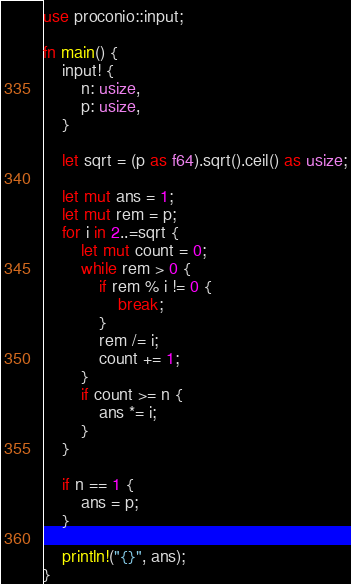Convert code to text. <code><loc_0><loc_0><loc_500><loc_500><_Rust_>use proconio::input;

fn main() {
    input! {
        n: usize,
        p: usize,
    }

    let sqrt = (p as f64).sqrt().ceil() as usize;

    let mut ans = 1;
    let mut rem = p;
    for i in 2..=sqrt {
        let mut count = 0;
        while rem > 0 {
            if rem % i != 0 {
                break;
            } 
            rem /= i;
            count += 1;
        }
        if count >= n {
            ans *= i;
        }
    }

    if n == 1 {
        ans = p;
    }

    println!("{}", ans);
}
</code> 